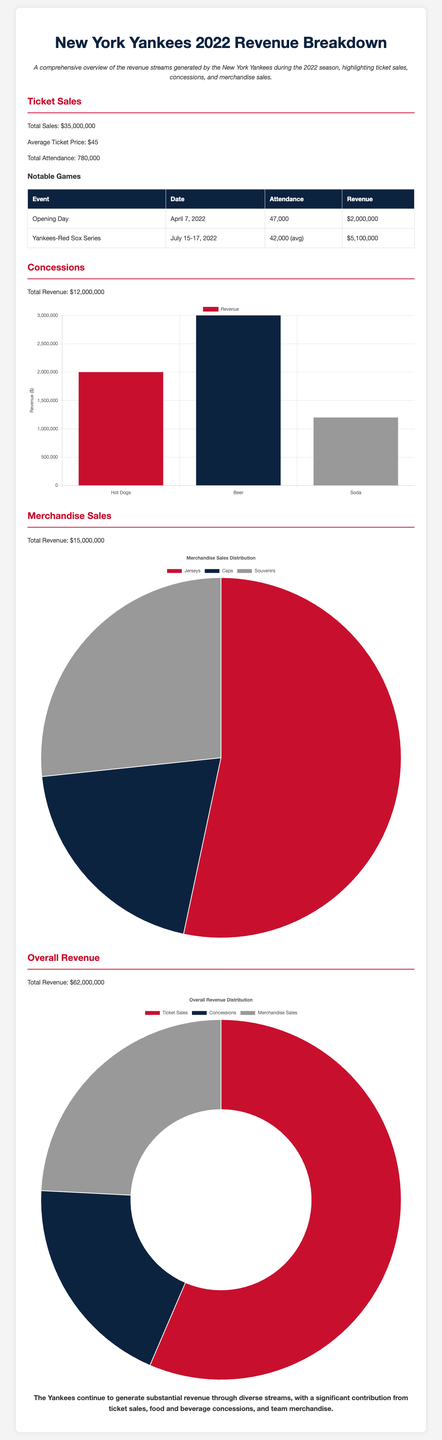what was the total ticket sales revenue? The total ticket sales revenue is provided directly in the document as $35,000,000.
Answer: $35,000,000 what is the average ticket price? The average ticket price is stated in the document as $45.
Answer: $45 how many games were highlighted as notable? There are two notable games mentioned in the document.
Answer: 2 what was the total revenue from concessions? The total revenue from concessions is listed as $12,000,000.
Answer: $12,000,000 which event had the highest revenue? The Opening Day generated the highest revenue of $2,000,000.
Answer: Opening Day what was the average attendance during the Yankees-Red Sox series? The average attendance during the Yankees-Red Sox series is mentioned as 42,000.
Answer: 42,000 what percentage of total revenue comes from merchandise sales? Merchandise sales generated $15,000,000 out of a total revenue of $62,000,000, which is approximately 24.19%.
Answer: 24.19% which item generated the most concession revenue? Beer generated the most concession revenue at $3,000,000.
Answer: Beer what is the total attendance for the 2022 season? The total attendance for the Yankees in 2022 is given as 780,000.
Answer: 780,000 